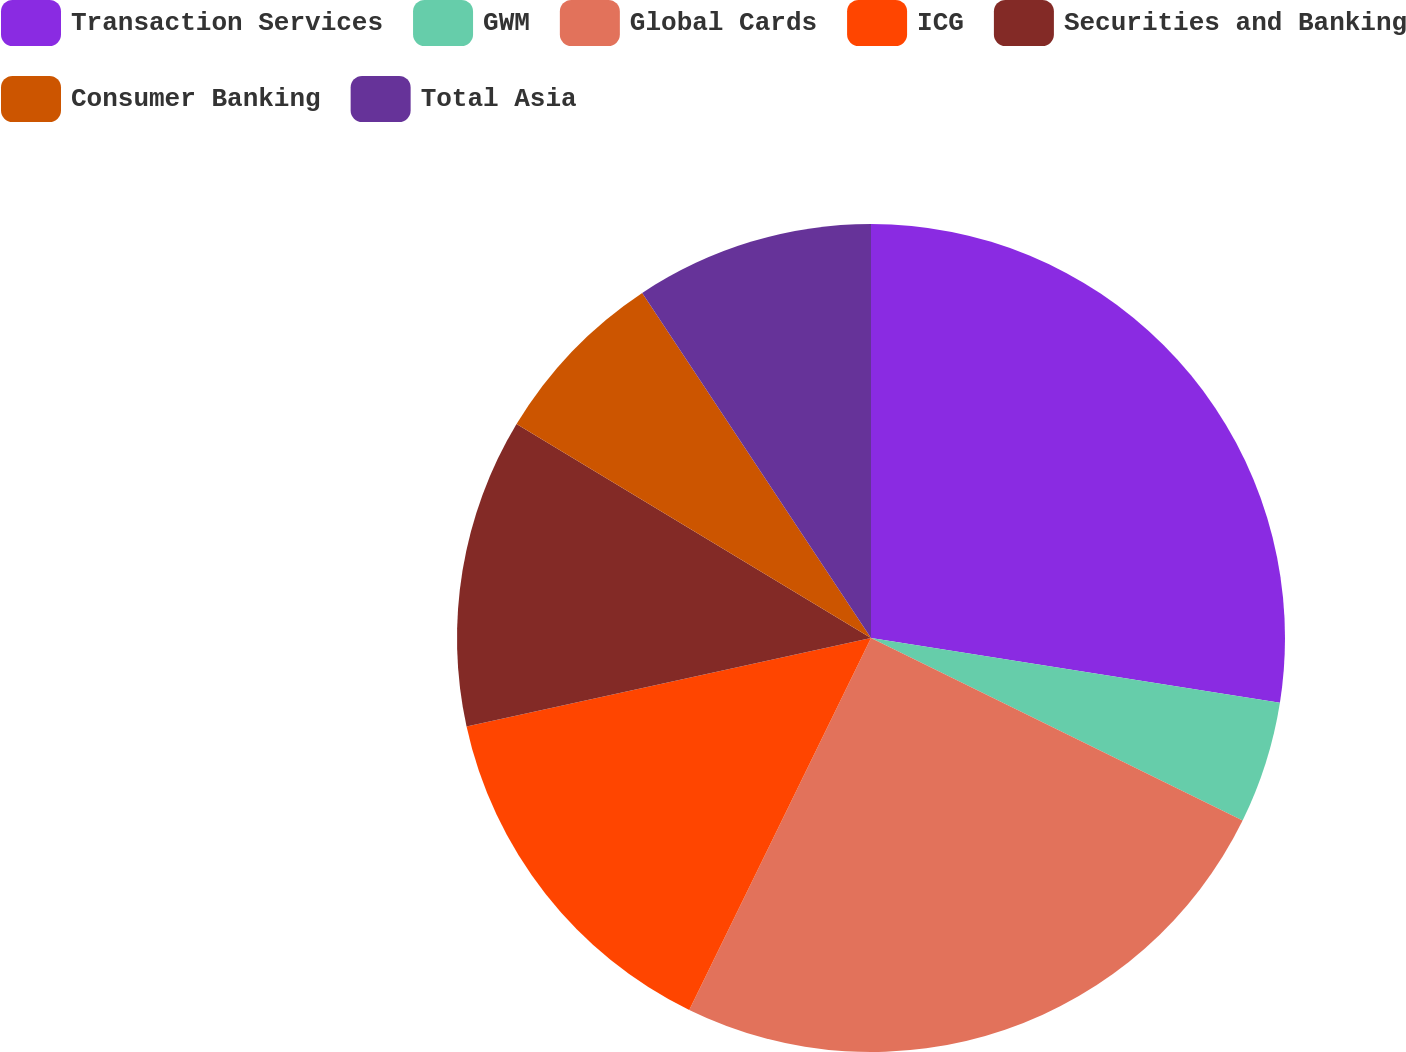Convert chart to OTSL. <chart><loc_0><loc_0><loc_500><loc_500><pie_chart><fcel>Transaction Services<fcel>GWM<fcel>Global Cards<fcel>ICG<fcel>Securities and Banking<fcel>Consumer Banking<fcel>Total Asia<nl><fcel>27.5%<fcel>4.77%<fcel>24.97%<fcel>14.34%<fcel>12.07%<fcel>7.04%<fcel>9.32%<nl></chart> 